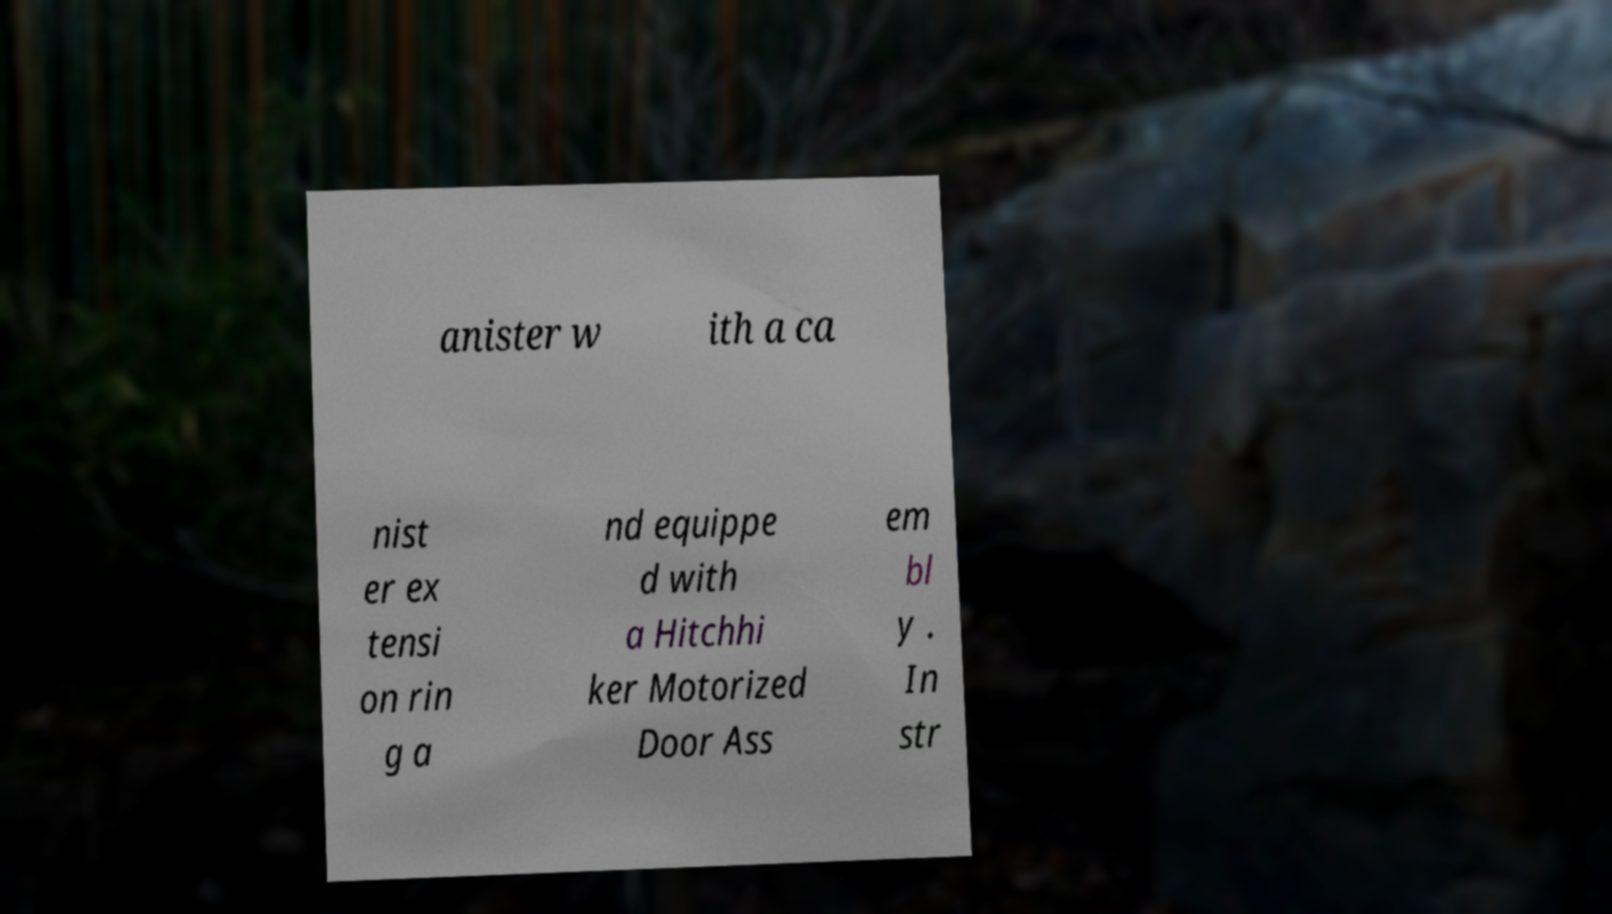Please read and relay the text visible in this image. What does it say? anister w ith a ca nist er ex tensi on rin g a nd equippe d with a Hitchhi ker Motorized Door Ass em bl y . In str 